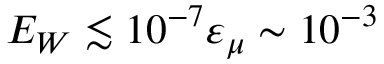Convert formula to latex. <formula><loc_0><loc_0><loc_500><loc_500>E _ { W } \lesssim 1 0 ^ { - 7 } \varepsilon _ { \mu } \sim 1 0 ^ { - 3 }</formula> 